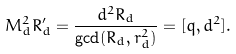<formula> <loc_0><loc_0><loc_500><loc_500>M _ { d } ^ { 2 } R _ { d } ^ { \prime } = \frac { d ^ { 2 } R _ { d } } { \gcd ( R _ { d } , r _ { d } ^ { 2 } ) } = [ q , d ^ { 2 } ] .</formula> 